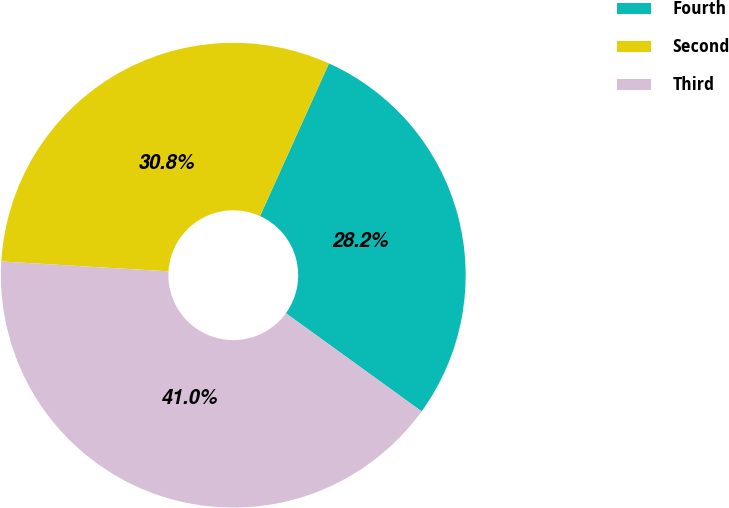Convert chart to OTSL. <chart><loc_0><loc_0><loc_500><loc_500><pie_chart><fcel>Fourth<fcel>Second<fcel>Third<nl><fcel>28.21%<fcel>30.81%<fcel>40.98%<nl></chart> 